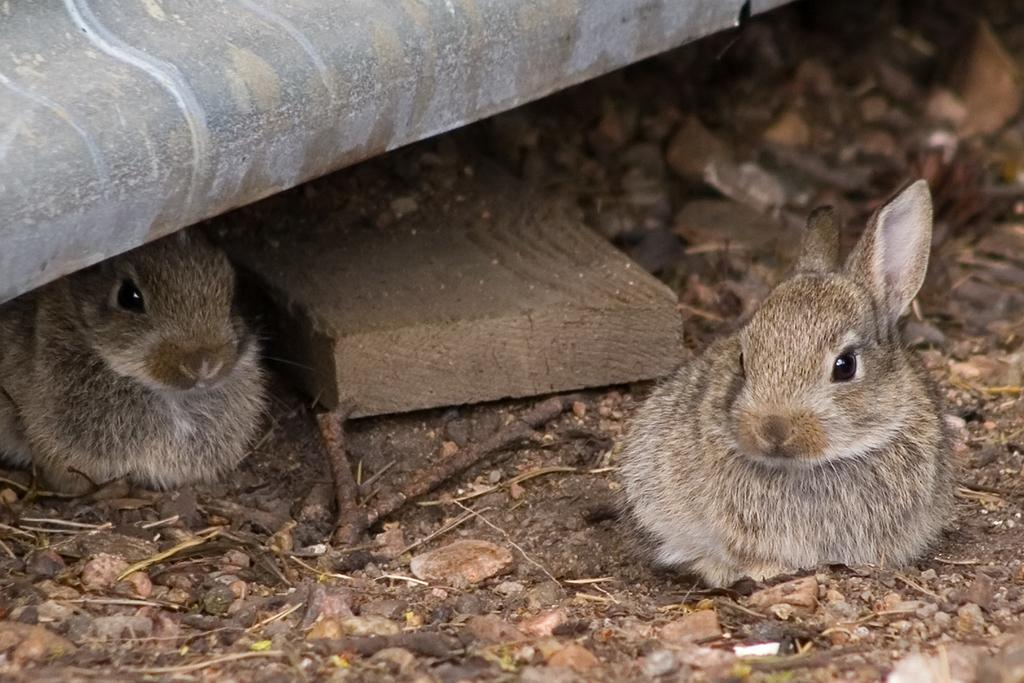What type of surface can be seen in the image? There is ground visible in the image. What object is made of wood and present in the image? There is a wooden log in the image. How many animals are in the image, and what are their colors? There are two animals in the image, one cream-colored and one brown-colored. Where are the animals located in the image? The animals are on the ground. What can be seen at the top of the image? There is an object at the top of the image. How many hens are visible in the image? There are no hens present in the image. What type of celestial object can be seen at the top of the image? There is no celestial object visible in the image; it is an object on the ground. 